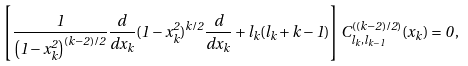<formula> <loc_0><loc_0><loc_500><loc_500>\left [ \frac { 1 } { \left ( 1 - x _ { k } ^ { 2 } \right ) ^ { ( k - 2 ) / 2 } } \frac { d } { d x _ { k } } ( 1 - x _ { k } ^ { 2 } ) ^ { k / 2 } \frac { d } { d x _ { k } } + l _ { k } ( l _ { k } + k - 1 ) \right ] C _ { l _ { k } , l _ { k - 1 } } ^ { ( ( k - 2 ) / 2 ) } ( x _ { k } ) = 0 \, ,</formula> 